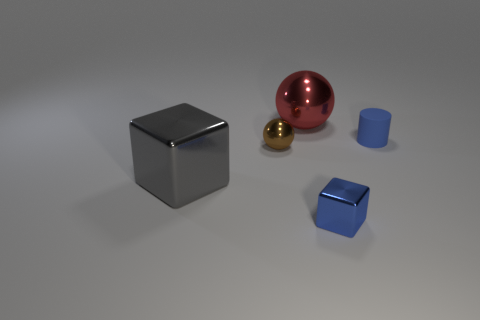Are there any other things that are the same material as the tiny cylinder?
Keep it short and to the point. No. Are there any other things that are the same shape as the tiny blue rubber thing?
Provide a short and direct response. No. There is a tiny blue metallic thing; does it have the same shape as the big gray metal thing in front of the tiny cylinder?
Your answer should be very brief. Yes. What is the shape of the small brown thing that is the same material as the gray block?
Your answer should be very brief. Sphere. Are there more things that are behind the large cube than tiny blue rubber cylinders that are behind the red ball?
Offer a terse response. Yes. How many objects are big cyan shiny blocks or blue rubber cylinders?
Your response must be concise. 1. How many other things are the same color as the tiny metallic block?
Offer a terse response. 1. The blue object that is the same size as the rubber cylinder is what shape?
Give a very brief answer. Cube. The shiny block on the right side of the gray object is what color?
Provide a short and direct response. Blue. How many objects are either metal spheres that are in front of the red metal sphere or large shiny objects that are behind the big gray metallic cube?
Ensure brevity in your answer.  2. 